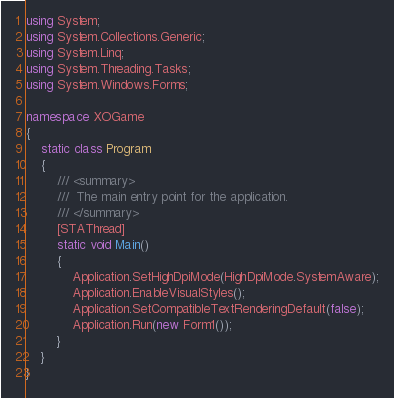Convert code to text. <code><loc_0><loc_0><loc_500><loc_500><_C#_>using System;
using System.Collections.Generic;
using System.Linq;
using System.Threading.Tasks;
using System.Windows.Forms;

namespace XOGame
{
    static class Program
    {
        /// <summary>
        ///  The main entry point for the application.
        /// </summary>
        [STAThread]
        static void Main()
        {
            Application.SetHighDpiMode(HighDpiMode.SystemAware);
            Application.EnableVisualStyles();
            Application.SetCompatibleTextRenderingDefault(false);
            Application.Run(new Form1());
        }
    }
}
</code> 